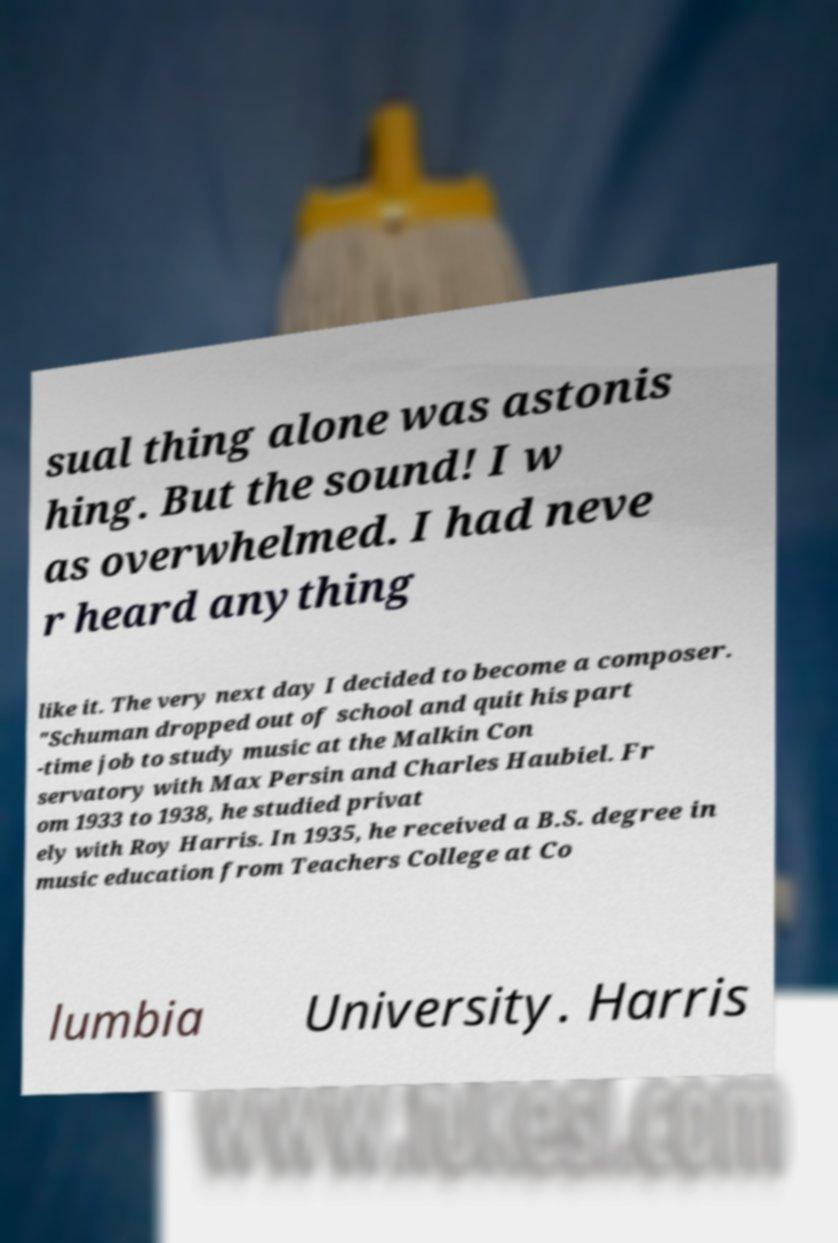What messages or text are displayed in this image? I need them in a readable, typed format. sual thing alone was astonis hing. But the sound! I w as overwhelmed. I had neve r heard anything like it. The very next day I decided to become a composer. "Schuman dropped out of school and quit his part -time job to study music at the Malkin Con servatory with Max Persin and Charles Haubiel. Fr om 1933 to 1938, he studied privat ely with Roy Harris. In 1935, he received a B.S. degree in music education from Teachers College at Co lumbia University. Harris 